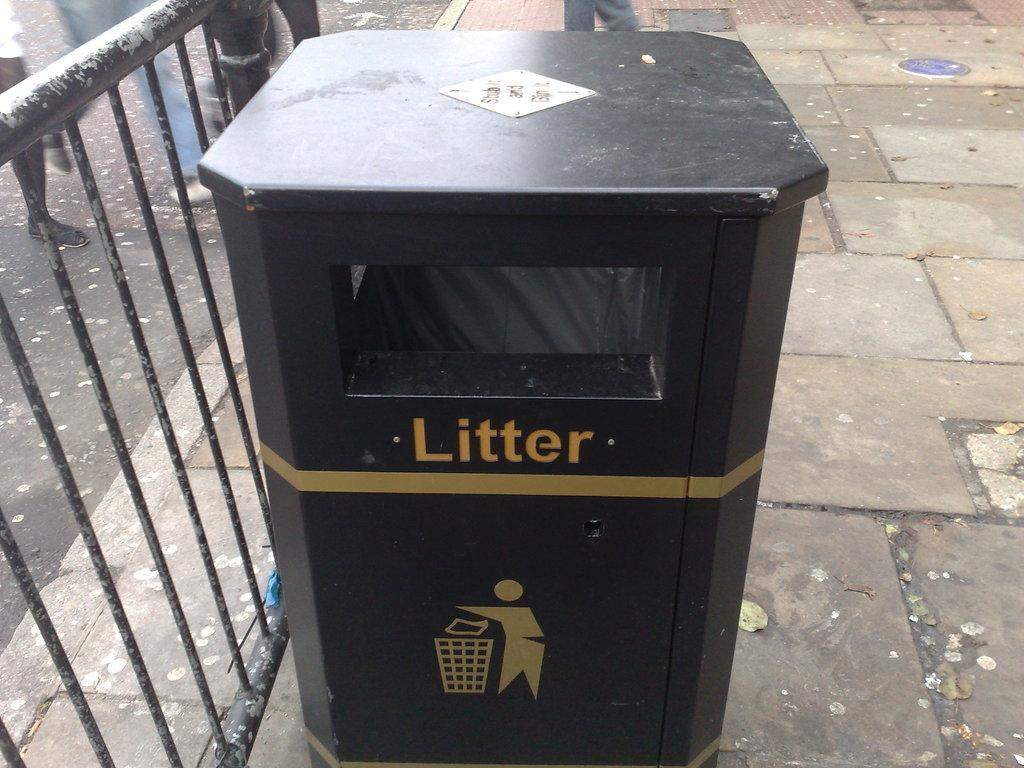<image>
Summarize the visual content of the image. A black trash can has the word Litter painted on it with an image of a person throwing away their trash. 